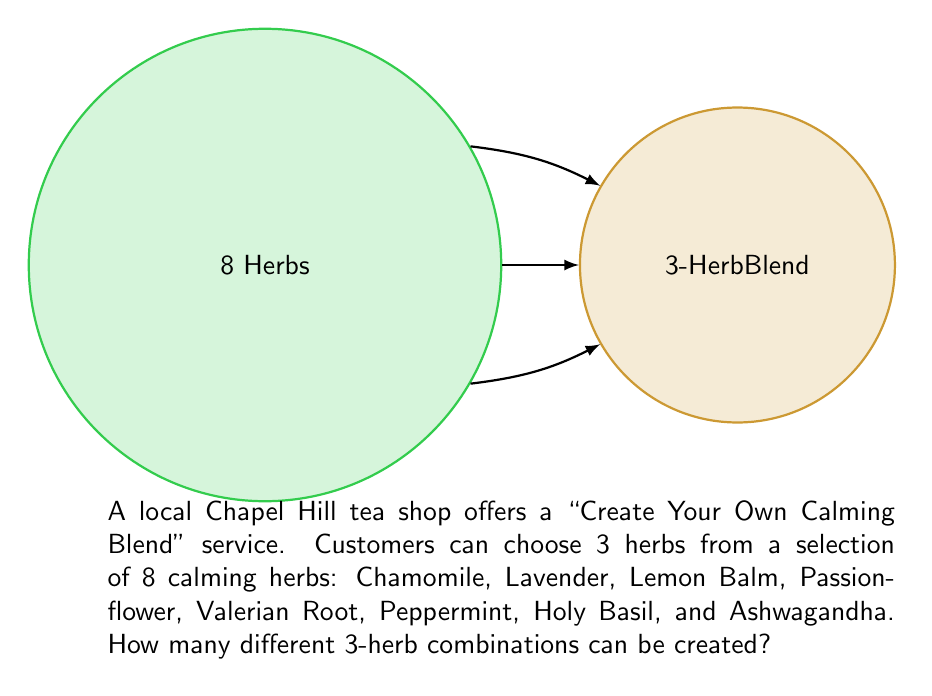Give your solution to this math problem. Let's approach this step-by-step:

1) This is a combination problem. We are selecting 3 herbs out of 8, where the order doesn't matter (e.g., Chamomile + Lavender + Lemon Balm is the same blend as Lavender + Lemon Balm + Chamomile).

2) The formula for combinations is:

   $$C(n,r) = \frac{n!}{r!(n-r)!}$$

   Where $n$ is the total number of items to choose from, and $r$ is the number of items being chosen.

3) In this case, $n = 8$ (total herbs) and $r = 3$ (herbs in each blend).

4) Let's substitute these values into our formula:

   $$C(8,3) = \frac{8!}{3!(8-3)!} = \frac{8!}{3!5!}$$

5) Expand this:
   
   $$\frac{8 \times 7 \times 6 \times 5!}{(3 \times 2 \times 1) \times 5!}$$

6) The $5!$ cancels out in the numerator and denominator:

   $$\frac{8 \times 7 \times 6}{3 \times 2 \times 1} = \frac{336}{6} = 56$$

Therefore, there are 56 different 3-herb combinations possible.
Answer: 56 